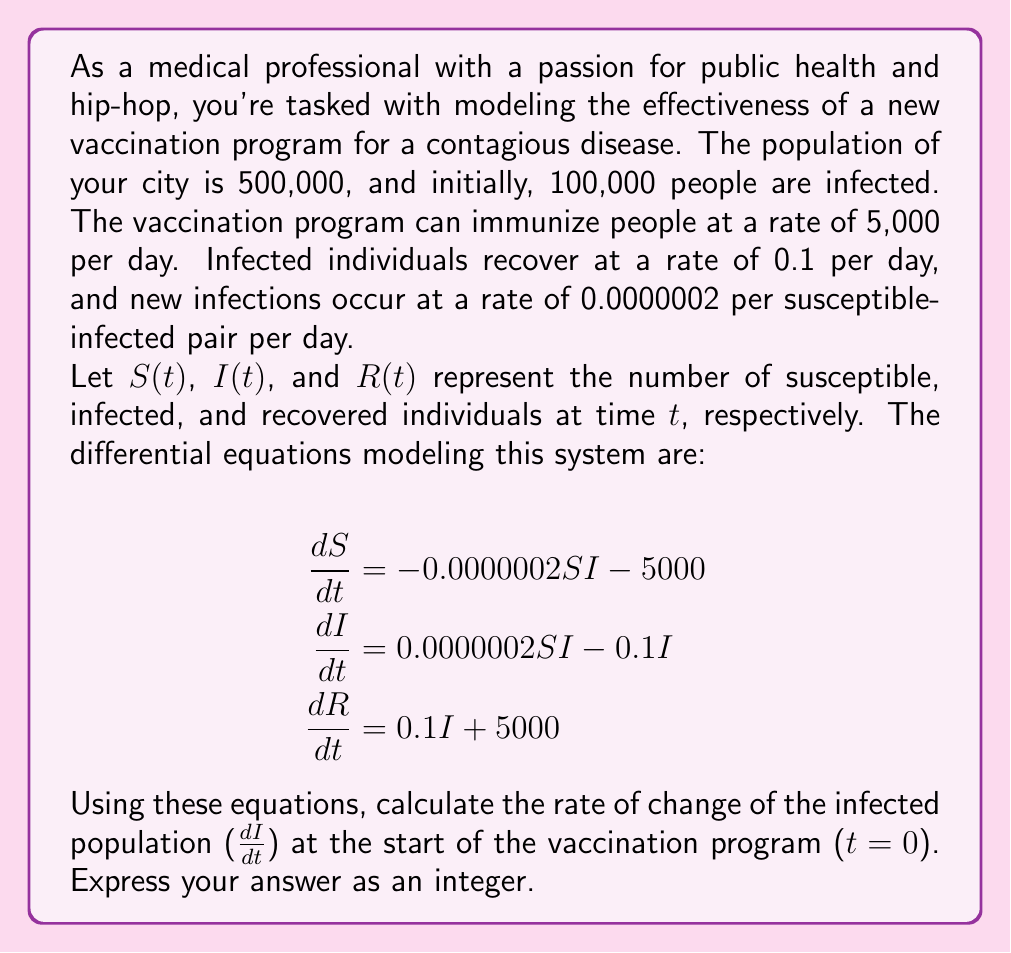Teach me how to tackle this problem. To solve this problem, we need to follow these steps:

1. Identify the initial values for $S$, $I$, and $R$.
2. Substitute these values into the equation for $\frac{dI}{dt}$.
3. Calculate the result.

Step 1: Initial values
- Total population = 500,000
- Initially infected = 100,000
- Initially susceptible = 500,000 - 100,000 = 400,000
- Initially recovered = 0

So, at $t=0$:
$S(0) = 400,000$
$I(0) = 100,000$
$R(0) = 0$

Step 2: Substitute into the equation for $\frac{dI}{dt}$

$$\frac{dI}{dt} = 0.0000002SI - 0.1I$$

Substituting the initial values:

$$\frac{dI}{dt} = 0.0000002 \cdot 400,000 \cdot 100,000 - 0.1 \cdot 100,000$$

Step 3: Calculate the result

$$\begin{align}
\frac{dI}{dt} &= 8,000 - 10,000 \\
&= -2,000
\end{align}$$

The negative value indicates that the infected population is decreasing at the start of the vaccination program.
Answer: -2000 